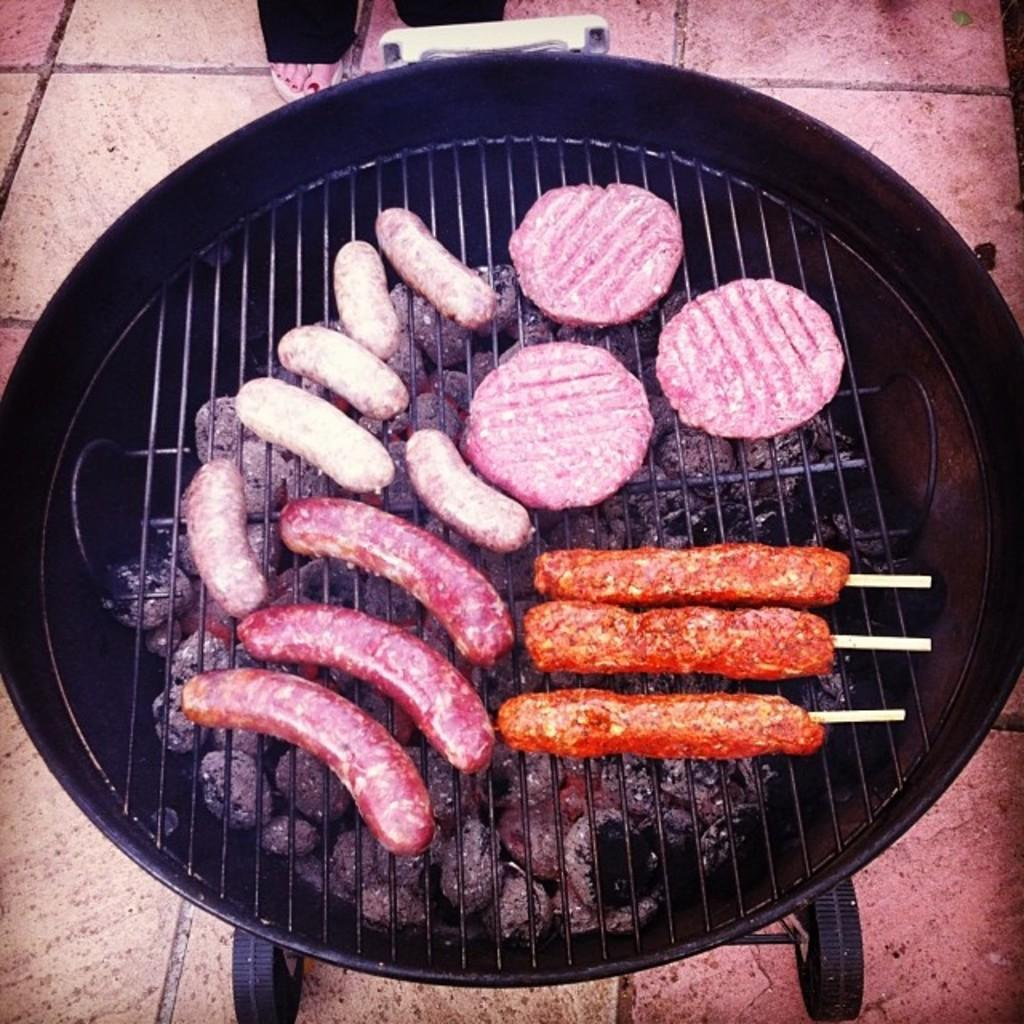What is the main object in the center of the image? There is a grill in the center of the image. What is being cooked or prepared on the grill? Food items are present on the grill. What can be seen at the bottom of the image? There is a floor visible at the bottom of the image. Can you describe any part of a person in the image? A person's leg is visible at the top of the image. What type of twig is being used to stir the food on the grill? There is no twig present in the image; the food items on the grill are not being stirred. Can you tell me the color of the shoe worn by the person in the image? There is no shoe visible in the image, only a person's leg is present. 